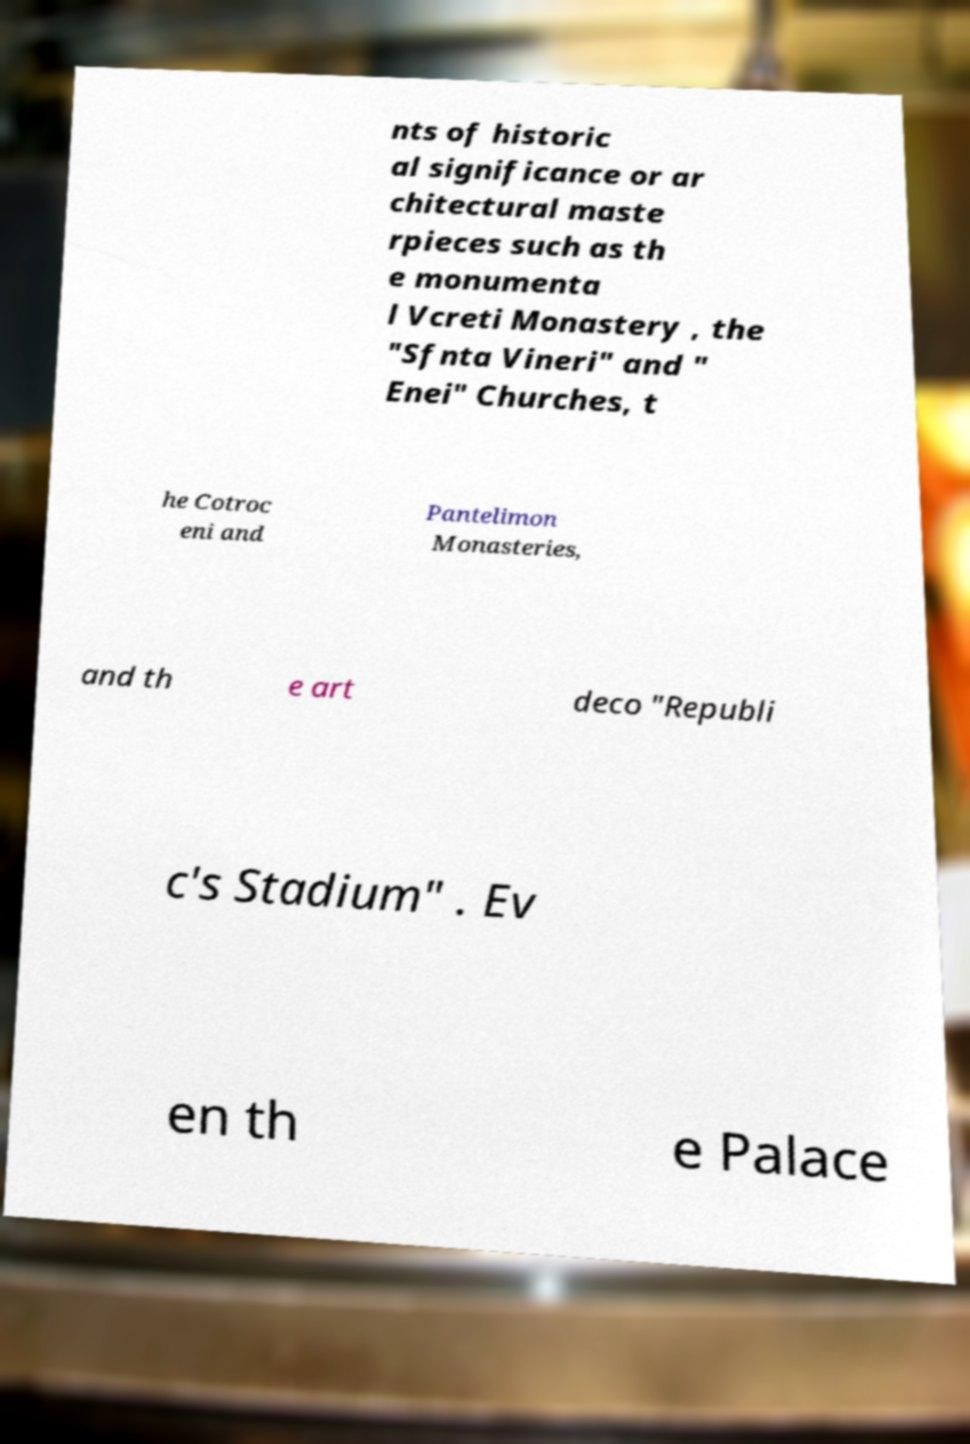There's text embedded in this image that I need extracted. Can you transcribe it verbatim? nts of historic al significance or ar chitectural maste rpieces such as th e monumenta l Vcreti Monastery , the "Sfnta Vineri" and " Enei" Churches, t he Cotroc eni and Pantelimon Monasteries, and th e art deco "Republi c's Stadium" . Ev en th e Palace 